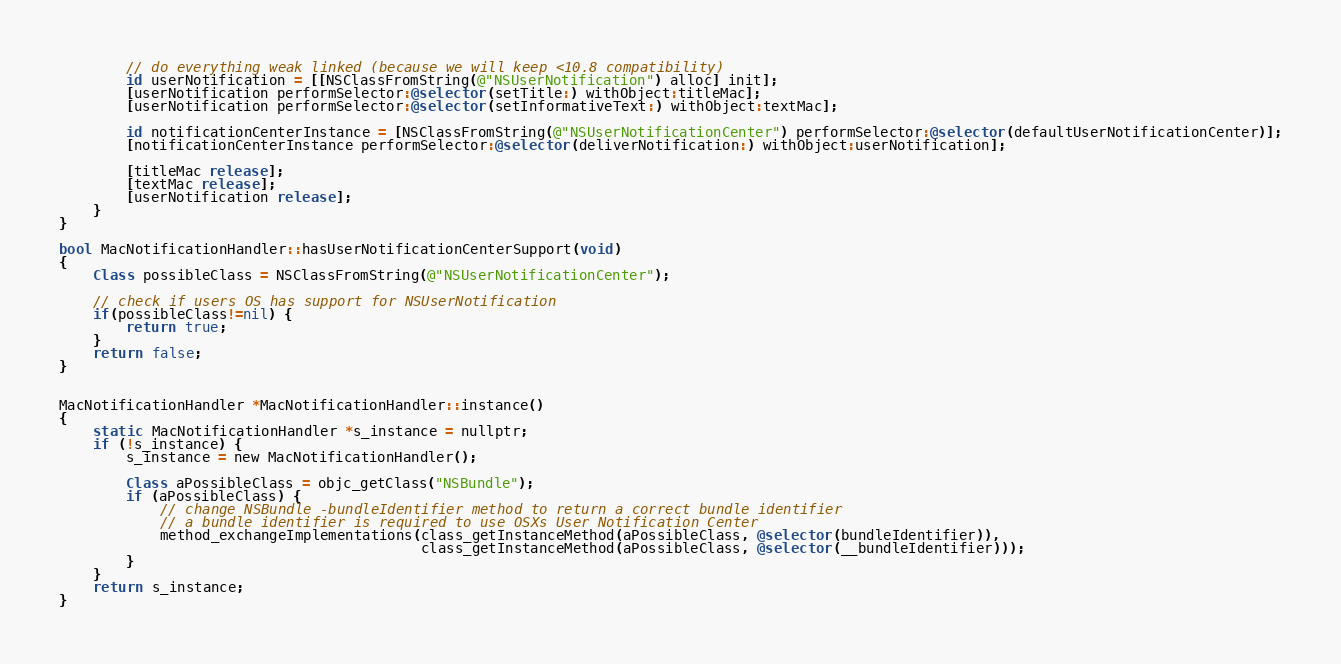<code> <loc_0><loc_0><loc_500><loc_500><_ObjectiveC_>
        // do everything weak linked (because we will keep <10.8 compatibility)
        id userNotification = [[NSClassFromString(@"NSUserNotification") alloc] init];
        [userNotification performSelector:@selector(setTitle:) withObject:titleMac];
        [userNotification performSelector:@selector(setInformativeText:) withObject:textMac];

        id notificationCenterInstance = [NSClassFromString(@"NSUserNotificationCenter") performSelector:@selector(defaultUserNotificationCenter)];
        [notificationCenterInstance performSelector:@selector(deliverNotification:) withObject:userNotification];

        [titleMac release];
        [textMac release];
        [userNotification release];
    }
}

bool MacNotificationHandler::hasUserNotificationCenterSupport(void)
{
    Class possibleClass = NSClassFromString(@"NSUserNotificationCenter");

    // check if users OS has support for NSUserNotification
    if(possibleClass!=nil) {
        return true;
    }
    return false;
}


MacNotificationHandler *MacNotificationHandler::instance()
{
    static MacNotificationHandler *s_instance = nullptr;
    if (!s_instance) {
        s_instance = new MacNotificationHandler();

        Class aPossibleClass = objc_getClass("NSBundle");
        if (aPossibleClass) {
            // change NSBundle -bundleIdentifier method to return a correct bundle identifier
            // a bundle identifier is required to use OSXs User Notification Center
            method_exchangeImplementations(class_getInstanceMethod(aPossibleClass, @selector(bundleIdentifier)),
                                           class_getInstanceMethod(aPossibleClass, @selector(__bundleIdentifier)));
        }
    }
    return s_instance;
}
</code> 